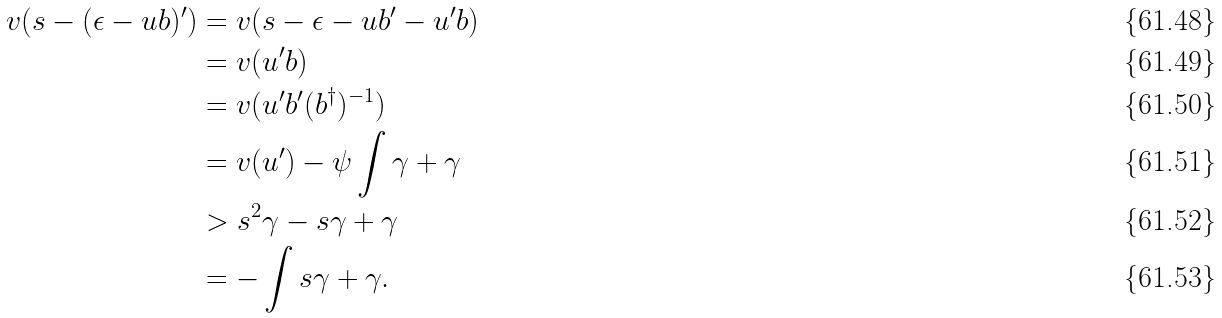<formula> <loc_0><loc_0><loc_500><loc_500>v ( s - ( \epsilon - u b ) ^ { \prime } ) & = v ( s - \epsilon - u b ^ { \prime } - u ^ { \prime } b ) \\ & = v ( u ^ { \prime } b ) \\ & = v ( u ^ { \prime } b ^ { \prime } ( b ^ { \dagger } ) ^ { - 1 } ) \\ & = v ( u ^ { \prime } ) - \psi \int \gamma + \gamma \\ & > s ^ { 2 } \gamma - s \gamma + \gamma \\ & = - \int s \gamma + \gamma .</formula> 